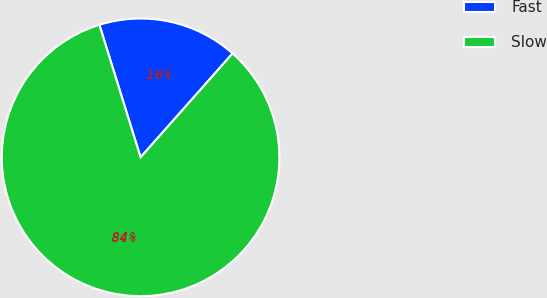Convert chart. <chart><loc_0><loc_0><loc_500><loc_500><pie_chart><fcel>Fast<fcel>Slow<nl><fcel>16.33%<fcel>83.67%<nl></chart> 